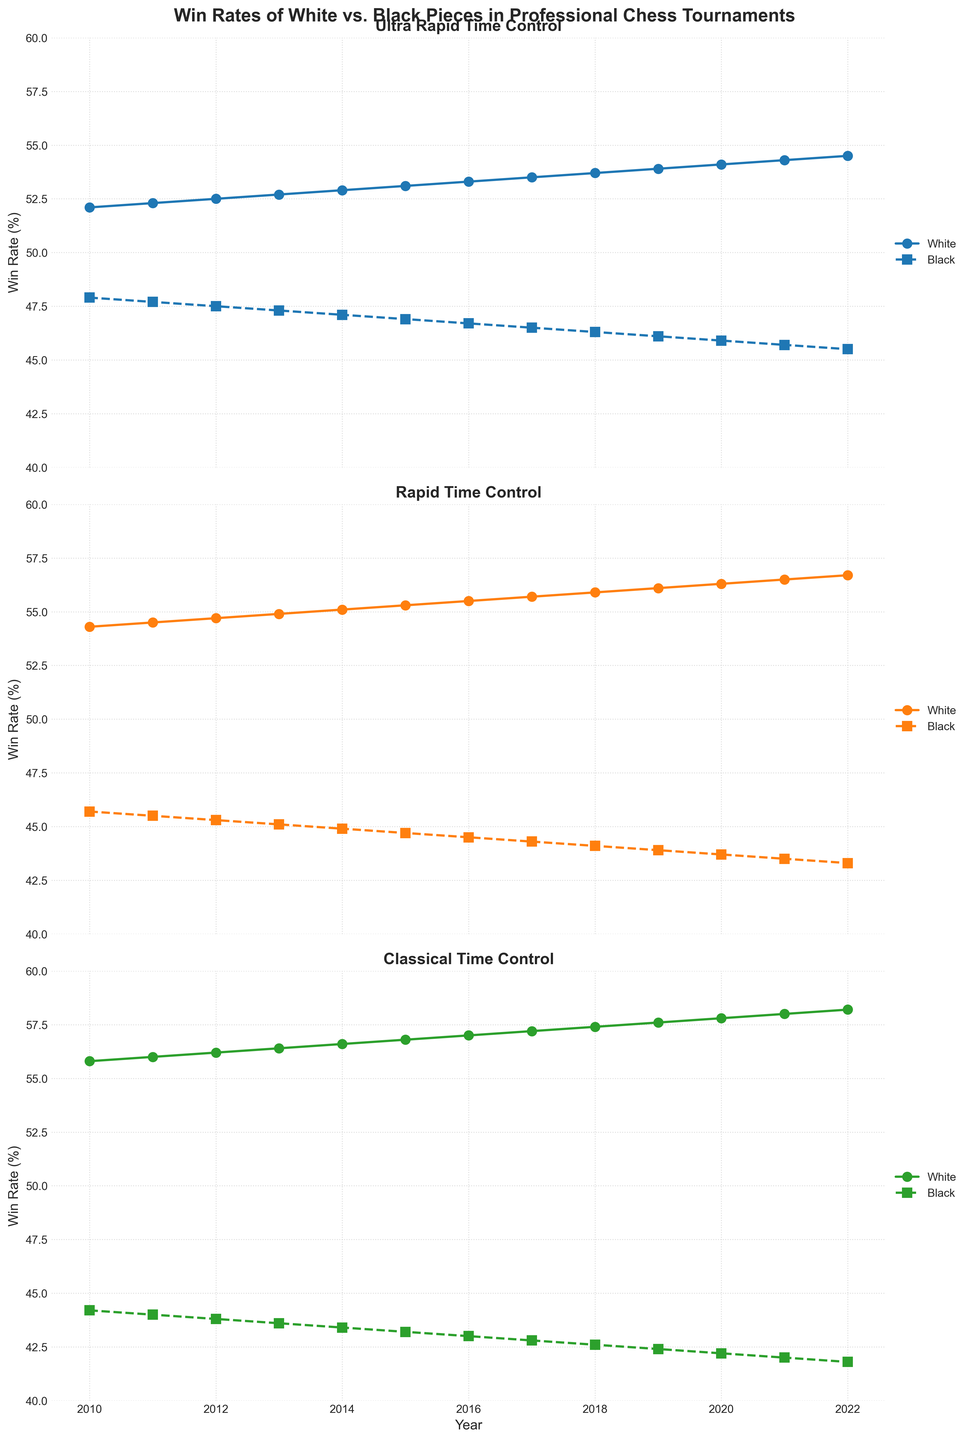What was the win rate of White pieces in Classical time control in 2010? Refer to the line chart for the Classical time control subplot. In 2010, the win rate of White pieces in Classical time control is shown by a dot on the solid line.
Answer: 55.8% Between which years did the win rate of Black pieces in Ultra Rapid time control increase? Look at the dashed line in the Ultra Rapid subplot. Identify the years where data points show an upward trend.
Answer: None Calculate the average win rate of Black pieces in Rapid time control from 2012 to 2016. Look at the dashed line in the Rapid subplot for years 2012 to 2016. The values are 45.3, 45.1, 44.9, 44.7, and 44.5. Sum these values and divide by 5. (45.3 + 45.1 + 44.9 + 44.7 + 44.5) / 5 = 44.9
Answer: 44.9% Compare the win rate increase of White pieces in Ultra Rapid vs. Classical from 2010 to 2022. Which increased more? Find the difference in win rate of White pieces in Ultra Rapid and Classical between 2010 and 2022. Ultra Rapid increased from 52.1 to 54.5 (54.5 - 52.1 = 2.4). Classical increased from 55.8 to 58.2 (58.2 - 55.8 = 2.4). Both have the same increase.
Answer: Same Which time control consistently shows the highest win rates for White pieces? Observe all subplots and compare the solid lines. Identify the time control with the highest values consistently.
Answer: Classical Which time control showed the smallest difference in win rates between White and Black pieces in 2015? Calculate the difference between White and Black win rates for each time control in 2015. Ultra Rapid (53.1 – 46.9 = 6.2), Rapid (55.3 – 44.7 = 10.6), Classical (56.8 – 43.2 = 13.6). The smallest difference is in Ultra Rapid.
Answer: Ultra Rapid Describe the trend of Black pieces' win rates in Classical time control from 2010 to 2022. Identify the trend of the dashed line in the Classical subplot. Observing from 2010 to 2022, Black win rates in Classical time control show a consistent decline from 44.2 to 41.8.
Answer: Declining Calculate the win rate difference for White pieces between 2010 and 2022 in Rapid time control. Look at the solid line in the Rapid subplot for 2010 and 2022. In 2010, it's 54.3, and in 2022, it's 56.7. The difference is 56.7 - 54.3 = 2.4.
Answer: 2.4 Which year shows the equal win rates of White pieces in both Ultra Rapid and Rapid time control? Compare the solid lines in Ultra Rapid and Rapid subplots to find the year where win rates align. In 2014, both have rates of 52.9%.
Answer: 2014 